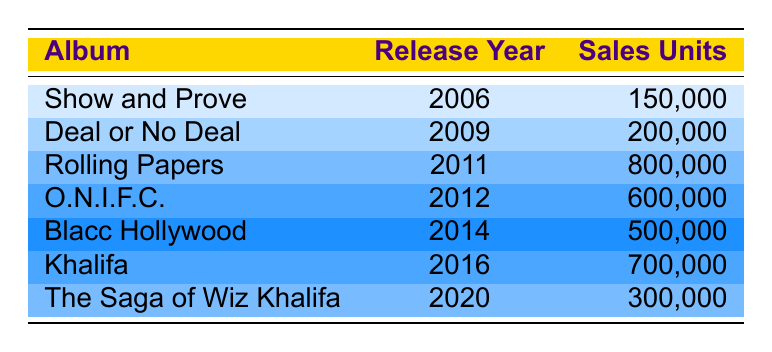What is the total sales units for all albums combined? To find the total sales units, sum the sales units of each album: 150000 + 200000 + 800000 + 600000 + 500000 + 700000 + 300000 = 3050000
Answer: 3050000 Which album had the highest sales units? Looking at the sales units of each album, "Rolling Papers" has the highest sales with 800000 units sold.
Answer: Rolling Papers What is the release year of the album "Khalifa"? The table shows that the album "Khalifa" was released in the year 2016.
Answer: 2016 Did "Blacc Hollywood" sell more units than "O.N.I.F.C."? "Blacc Hollywood" sold 500000 units, while "O.N.I.F.C." sold 600000 units. Since 500000 is less than 600000, the answer is no.
Answer: No What percentage of total album sales does "Show and Prove" contribute? First, calculate the total sales: 3050000. Then, find the percentage contribution of "Show and Prove": (150000 / 3050000) * 100 = 4.92%.
Answer: 4.92% What is the difference in sales units between the albums "Khalifa" and "The Saga of Wiz Khalifa"? "Khalifa" sold 700000 units and "The Saga of Wiz Khalifa" sold 300000 units. The difference is 700000 - 300000 = 400000.
Answer: 400000 What are the total sales units of the albums released between 2008 and 2013? The albums released during those years are "Deal or No Deal" (2009), "Rolling Papers" (2011), and "O.N.I.F.C." (2012). Their sales units are 200000, 800000, and 600000 respectively. Total sales = 200000 + 800000 + 600000 = 1600000.
Answer: 1600000 Was there an album released in 2014 that sold more than 400000 units? The only album released in 2014 is "Blacc Hollywood," which sold 500000 units. Since 500000 is more than 400000, the answer is yes.
Answer: Yes 